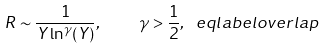<formula> <loc_0><loc_0><loc_500><loc_500>R \sim \frac { 1 } { Y \ln ^ { \gamma } ( Y ) } , \quad \gamma > \frac { 1 } { 2 } , \ e q l a b e l { o v e r l a p }</formula> 